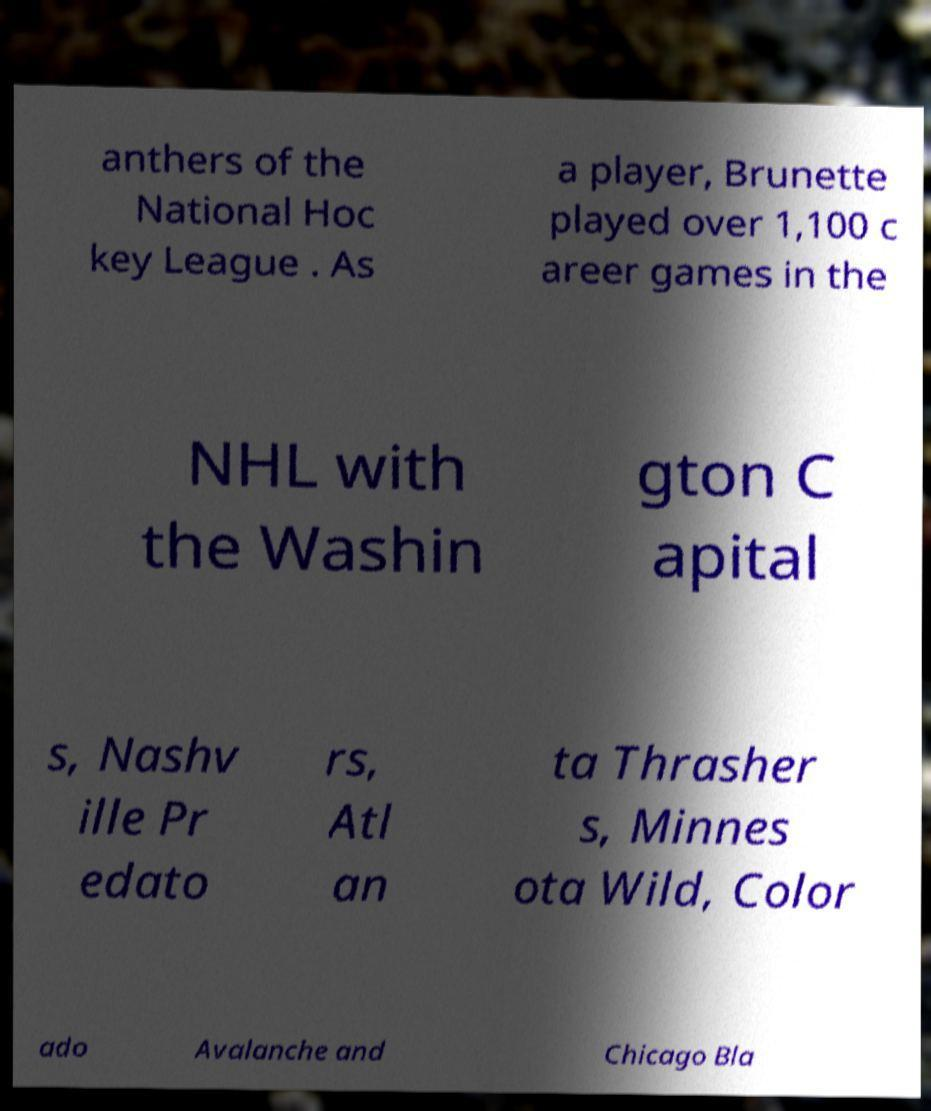I need the written content from this picture converted into text. Can you do that? anthers of the National Hoc key League . As a player, Brunette played over 1,100 c areer games in the NHL with the Washin gton C apital s, Nashv ille Pr edato rs, Atl an ta Thrasher s, Minnes ota Wild, Color ado Avalanche and Chicago Bla 